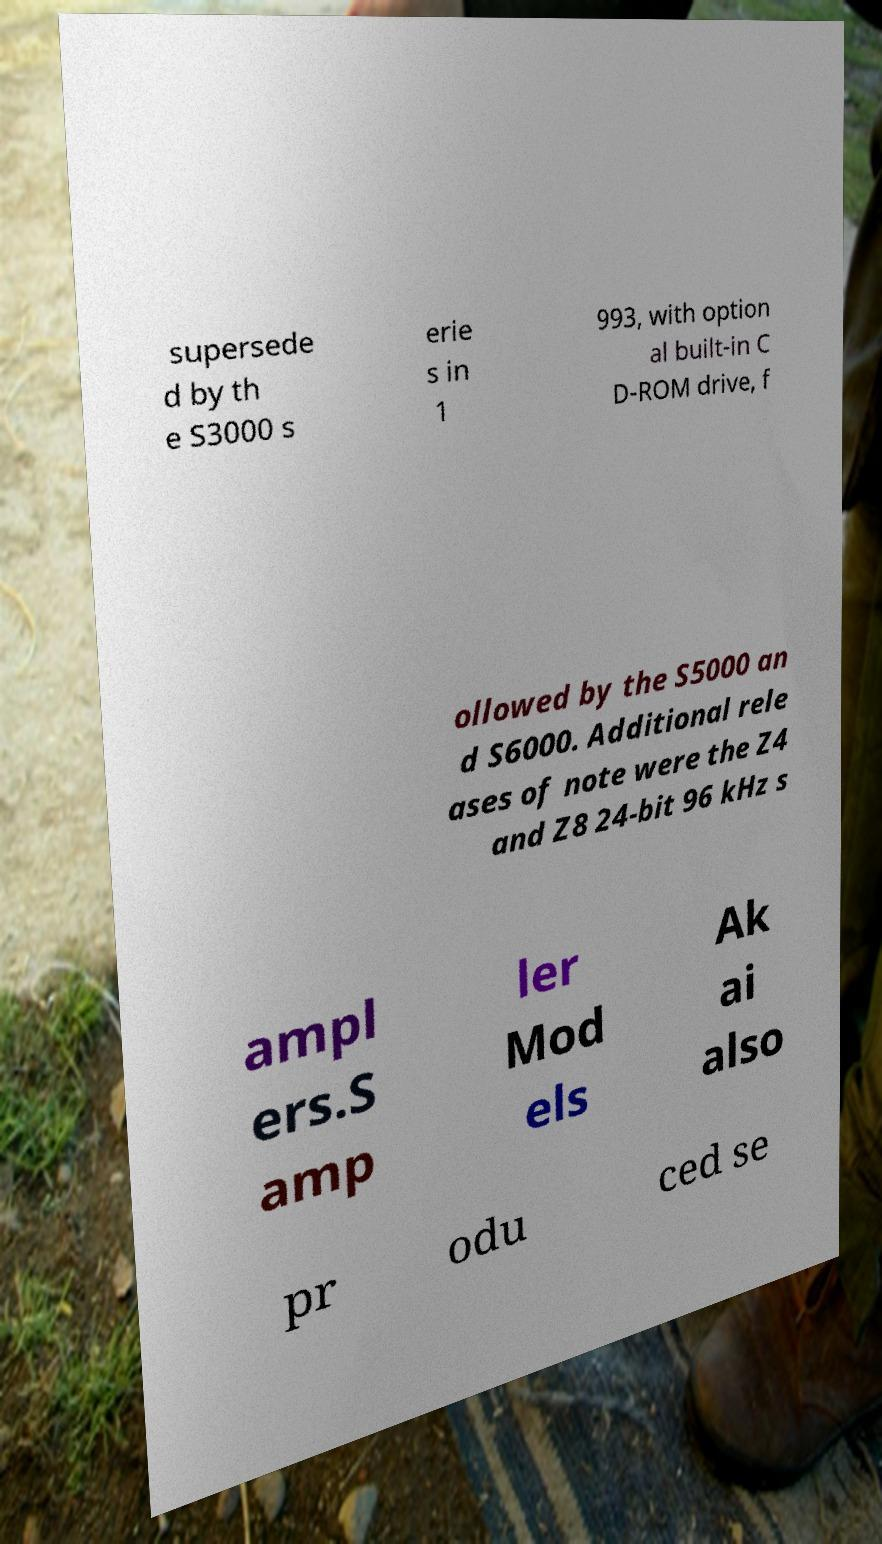Could you extract and type out the text from this image? supersede d by th e S3000 s erie s in 1 993, with option al built-in C D-ROM drive, f ollowed by the S5000 an d S6000. Additional rele ases of note were the Z4 and Z8 24-bit 96 kHz s ampl ers.S amp ler Mod els Ak ai also pr odu ced se 